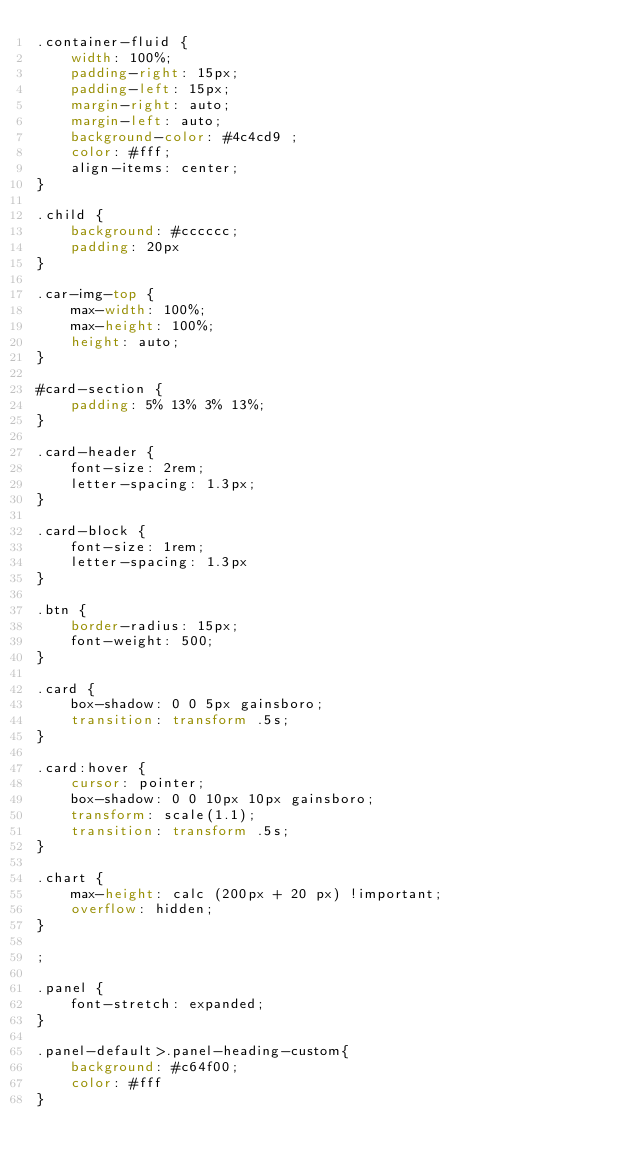Convert code to text. <code><loc_0><loc_0><loc_500><loc_500><_CSS_>.container-fluid {
    width: 100%;
    padding-right: 15px;
    padding-left: 15px;
    margin-right: auto;
    margin-left: auto;
    background-color: #4c4cd9 ;
    color: #fff;
    align-items: center;
}

.child {
    background: #cccccc;
    padding: 20px
}

.car-img-top {
    max-width: 100%;
    max-height: 100%;
    height: auto;
}

#card-section {
    padding: 5% 13% 3% 13%;
}

.card-header {
    font-size: 2rem;
    letter-spacing: 1.3px;
}

.card-block {
    font-size: 1rem;
    letter-spacing: 1.3px
}

.btn {
    border-radius: 15px;
    font-weight: 500;
}

.card {
    box-shadow: 0 0 5px gainsboro;
    transition: transform .5s;
}

.card:hover {
    cursor: pointer;
    box-shadow: 0 0 10px 10px gainsboro;
    transform: scale(1.1);
    transition: transform .5s;
}

.chart {
    max-height: calc (200px + 20 px) !important;
    overflow: hidden;
}

;

.panel {
    font-stretch: expanded;
}

.panel-default>.panel-heading-custom{
    background: #c64f00;
    color: #fff
}</code> 